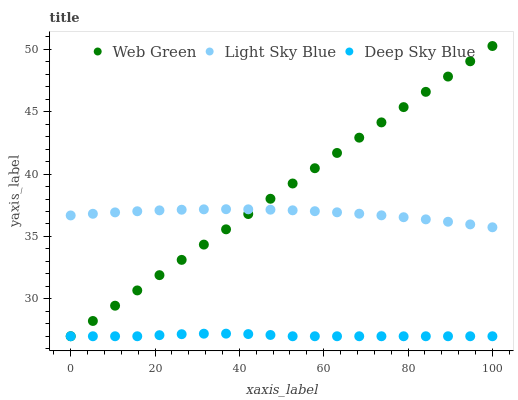Does Deep Sky Blue have the minimum area under the curve?
Answer yes or no. Yes. Does Web Green have the maximum area under the curve?
Answer yes or no. Yes. Does Web Green have the minimum area under the curve?
Answer yes or no. No. Does Deep Sky Blue have the maximum area under the curve?
Answer yes or no. No. Is Web Green the smoothest?
Answer yes or no. Yes. Is Deep Sky Blue the roughest?
Answer yes or no. Yes. Is Deep Sky Blue the smoothest?
Answer yes or no. No. Is Web Green the roughest?
Answer yes or no. No. Does Deep Sky Blue have the lowest value?
Answer yes or no. Yes. Does Web Green have the highest value?
Answer yes or no. Yes. Does Deep Sky Blue have the highest value?
Answer yes or no. No. Is Deep Sky Blue less than Light Sky Blue?
Answer yes or no. Yes. Is Light Sky Blue greater than Deep Sky Blue?
Answer yes or no. Yes. Does Light Sky Blue intersect Web Green?
Answer yes or no. Yes. Is Light Sky Blue less than Web Green?
Answer yes or no. No. Is Light Sky Blue greater than Web Green?
Answer yes or no. No. Does Deep Sky Blue intersect Light Sky Blue?
Answer yes or no. No. 